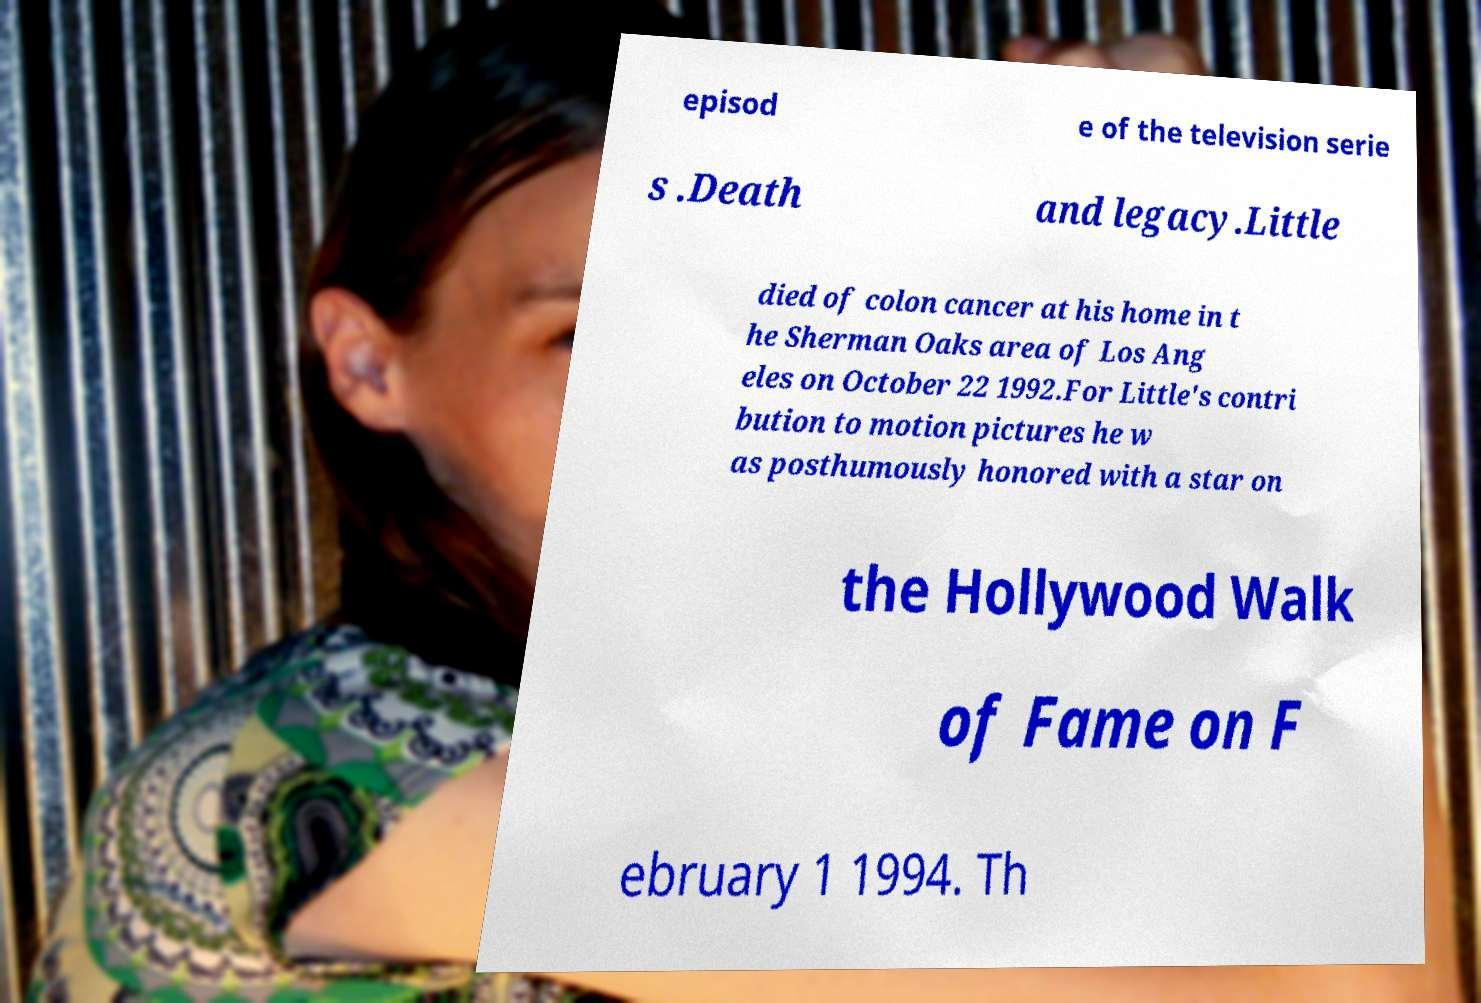Please read and relay the text visible in this image. What does it say? episod e of the television serie s .Death and legacy.Little died of colon cancer at his home in t he Sherman Oaks area of Los Ang eles on October 22 1992.For Little's contri bution to motion pictures he w as posthumously honored with a star on the Hollywood Walk of Fame on F ebruary 1 1994. Th 